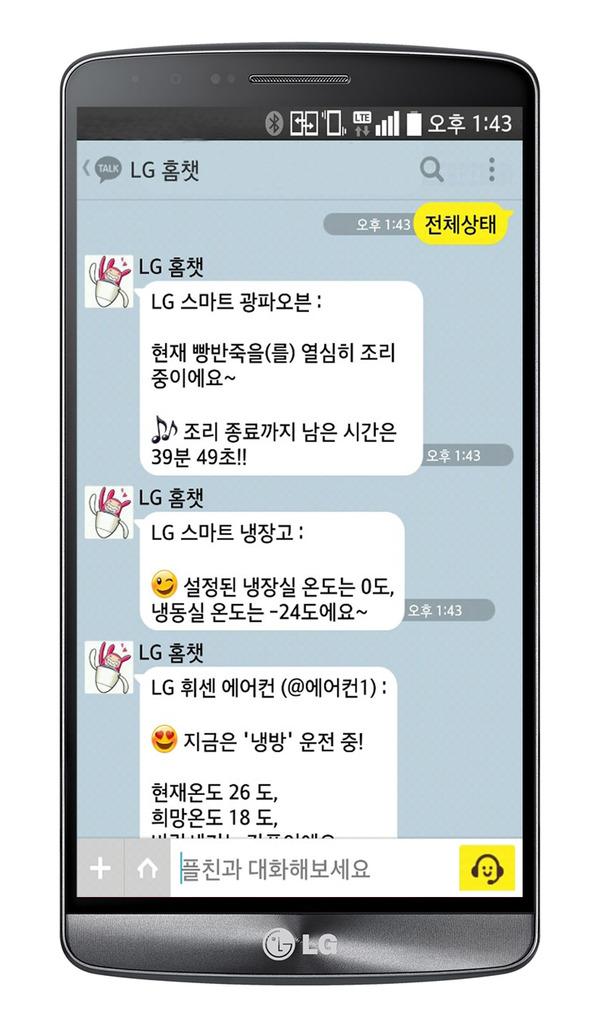What brand of phone is this?
Ensure brevity in your answer.  Lg. 